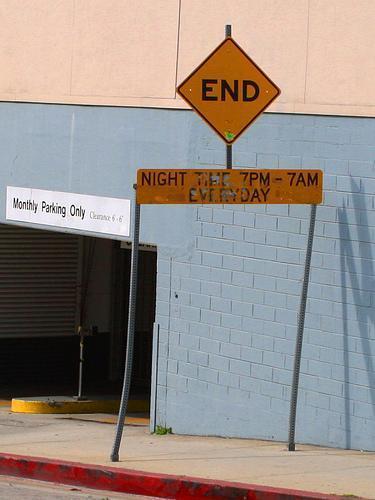How many signs are seen here?
Give a very brief answer. 3. How many people appear in this picture?
Give a very brief answer. 0. 